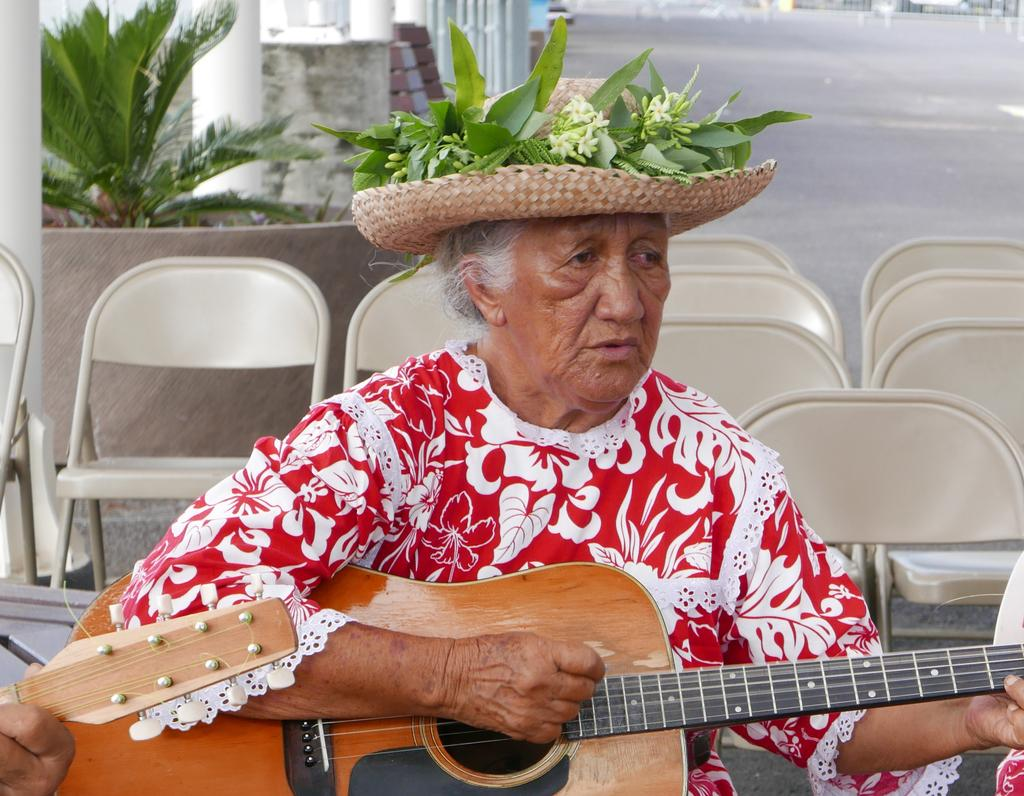What is the person in the image doing? The person is playing a guitar. What accessory is the person wearing? The person is wearing a hat. What type of furniture can be seen in the image? There are chairs in the image. What can be seen in the background of the image? There is a plant and a road in the background of the image. What type of paste is the person using to play the guitar in the image? There is no paste mentioned or visible in the image; the person is playing the guitar using their hands. Can you see any bones in the image? There are no bones visible in the image. 